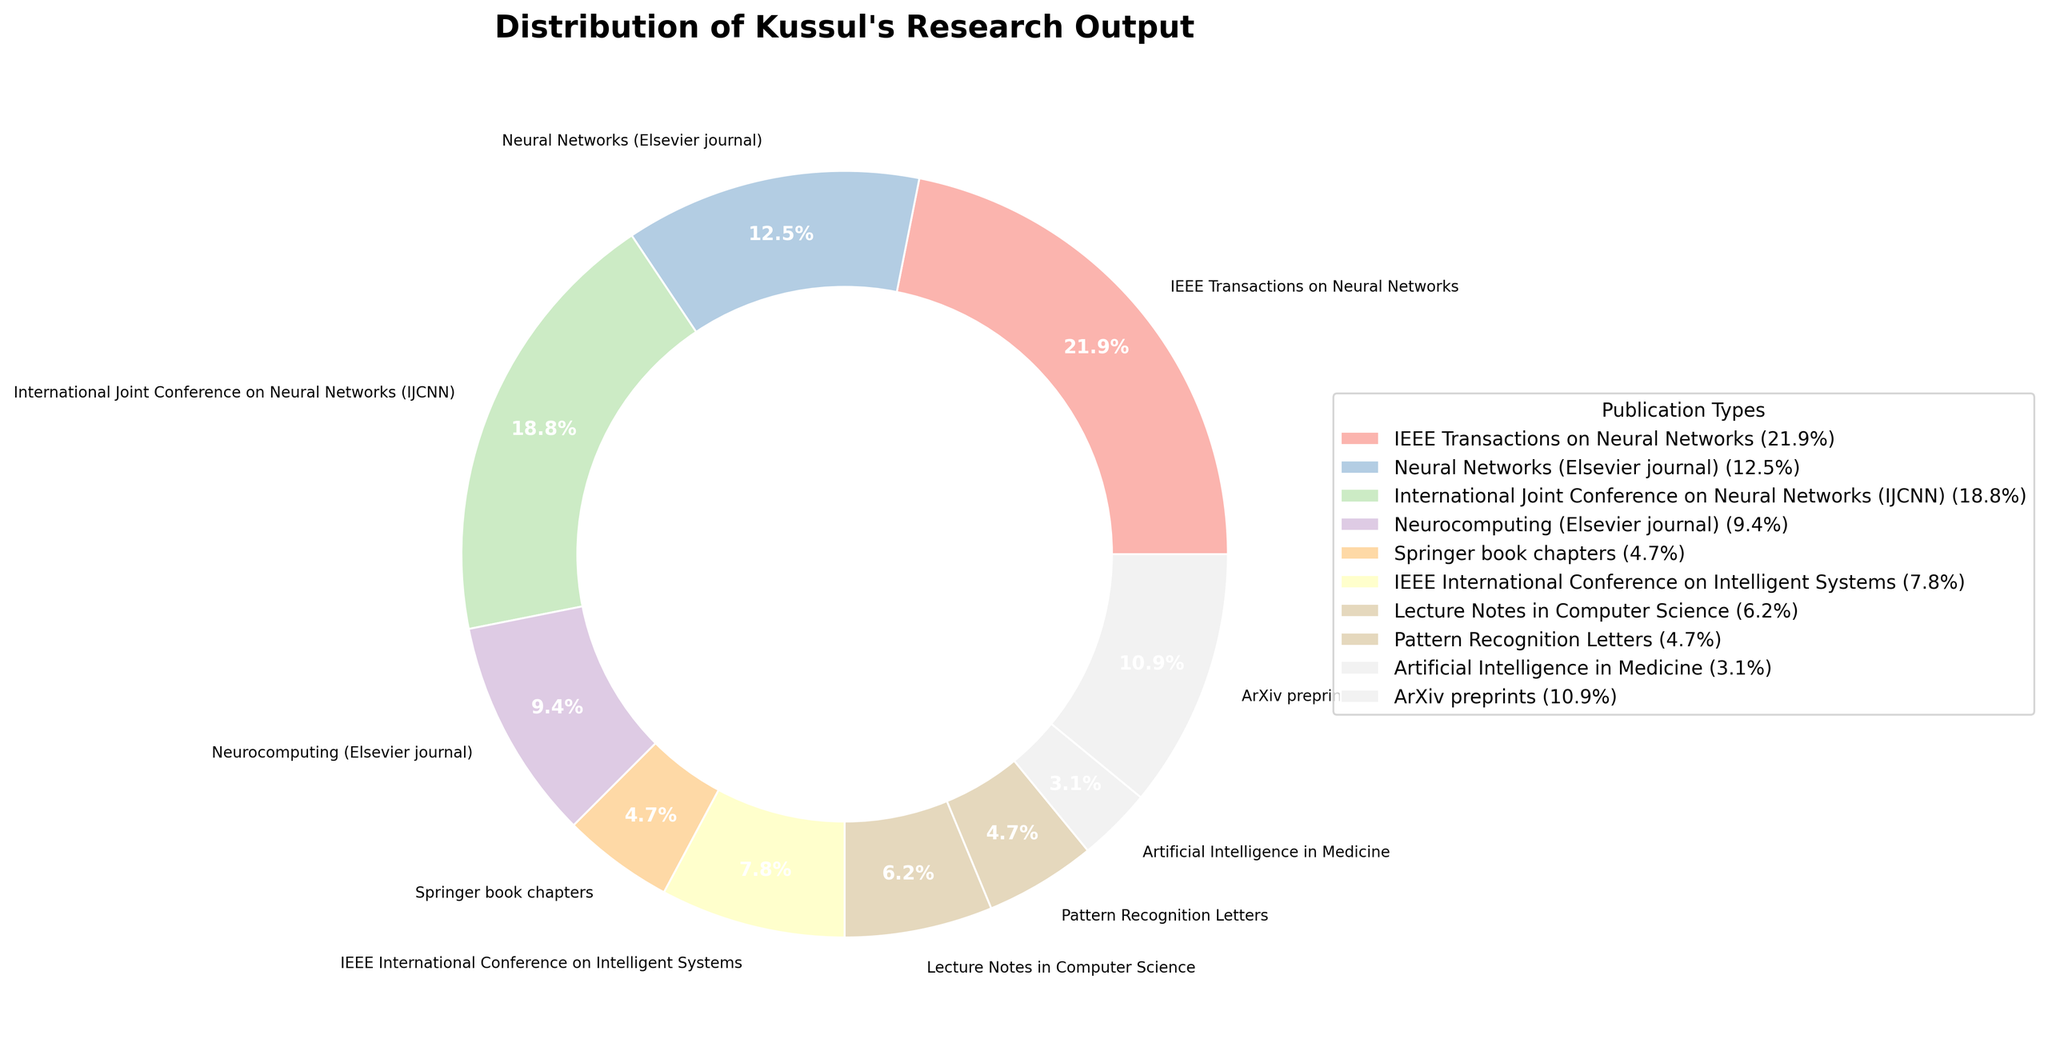Which publication type has the highest count in Kussul's research output? By examining the pie chart visually, the wedge representing "IEEE Transactions on Neural Networks" occupies the largest portion of the chart compared to the other publication types.
Answer: IEEE Transactions on Neural Networks What is the total percentage of publications from Elsevier journals? The two Elsevier journals in the data are "Neural Networks" and "Neurocomputing", with counts of 8 and 6 respectively. The total count is 8 + 6 = 14. The overall total count of all publications is 64. Therefore, the percentage is (14 / 64) * 100 ≈ 21.9%.
Answer: 21.9% Which has a greater count, ArXiv preprints or Springer book chapters? Comparing the sizes of the wedges visually, "ArXiv preprints" has a larger wedge than "Springer book chapters". The counts are 7 for ArXiv preprints and 3 for Springer book chapters.
Answer: ArXiv preprints What is the difference in count between the publication types with the highest and lowest counts? The highest count is 14 (IEEE Transactions on Neural Networks) and the lowest count is 2 (Artificial Intelligence in Medicine). The difference is 14 - 2 = 12.
Answer: 12 What percentage of publications is represented by conferences (IJCNN and IEEE International Conference on Intelligent Systems combined)? The counts are 12 for IJCNN and 5 for IEEE International Conference on Intelligent Systems. The combined count is 12 + 5 = 17. The total count of all publications is 64. Therefore, the percentage is (17 / 64) * 100 ≈ 26.6%.
Answer: 26.6% How many more publications are there in "IEEE Transactions on Neural Networks" compared to "Lecture Notes in Computer Science"? The counts are 14 for IEEE Transactions on Neural Networks and 4 for Lecture Notes in Computer Science. The difference is 14 - 4 = 10.
Answer: 10 Which publication types are represented by wedges with similar sizes in the pie chart? From the chart, "Lecture Notes in Computer Science" with count 4 and "Springer book chapters" with count 3 have very similar wedge sizes.
Answer: Lecture Notes in Computer Science and Springer book chapters What are the three most common publication types in Kussul's research output? By examining the relative sizes of the wedges in the pie chart, the three largest wedges represent "IEEE Transactions on Neural Networks" (14), "International Joint Conference on Neural Networks (IJCNN)" (12), and "Neural Networks (Elsevier journal)" (8).
Answer: IEEE Transactions on Neural Networks, International Joint Conference on Neural Networks (IJCNN), Neural Networks (Elsevier journal) How does the count of "Pattern Recognition Letters" compare to "Neurocomputing (Elsevier journal)"? From the chart, "Pattern Recognition Letters" has a count of 3, and "Neurocomputing (Elsevier journal)" has a count of 6. "Neurocomputing" has twice as many publications as "Pattern Recognition Letters".
Answer: Neurocomputing (Elsevier journal) What is the combined percentage of the least frequent publication types in the chart? The least frequent publication types are "Pattern Recognition Letters" (3), "Artificial Intelligence in Medicine" (2), and "Springer book chapters" (3). Their combined count is 3 + 2 + 3 = 8. The total count of all publications is 64. Therefore, the percentage is (8 / 64) * 100 = 12.5%.
Answer: 12.5% 